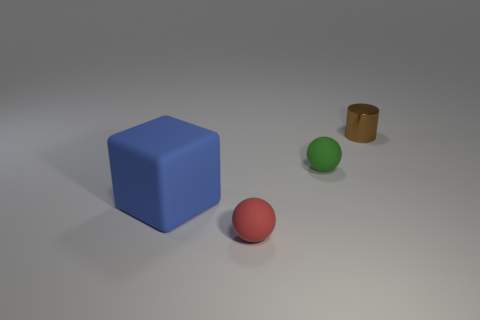Add 2 tiny red rubber objects. How many objects exist? 6 Subtract all cylinders. How many objects are left? 3 Subtract 1 blue cubes. How many objects are left? 3 Subtract all big shiny cylinders. Subtract all small brown metal cylinders. How many objects are left? 3 Add 2 small green spheres. How many small green spheres are left? 3 Add 1 red rubber balls. How many red rubber balls exist? 2 